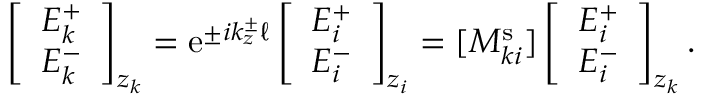<formula> <loc_0><loc_0><loc_500><loc_500>\left [ \begin{array} { l } { E _ { k } ^ { + } } \\ { E _ { k } ^ { - } } \end{array} \right ] _ { z _ { k } } = e ^ { \pm i k _ { z } ^ { \pm } \ell } \left [ \begin{array} { l } { E _ { i } ^ { + } } \\ { E _ { i } ^ { - } } \end{array} \right ] _ { z _ { i } } = [ M _ { k i } ^ { s } ] \left [ \begin{array} { l } { E _ { i } ^ { + } } \\ { E _ { i } ^ { - } } \end{array} \right ] _ { z _ { k } } .</formula> 